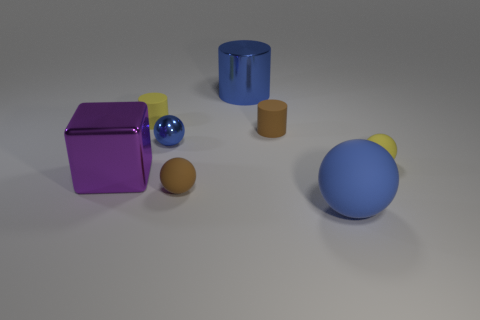Is the color of the large shiny cylinder the same as the large thing in front of the big purple metallic object?
Offer a terse response. Yes. What shape is the big blue metallic object?
Your answer should be compact. Cylinder. What number of big blocks have the same color as the tiny metal object?
Your response must be concise. 0. The big rubber thing that is the same shape as the small blue object is what color?
Provide a succinct answer. Blue. How many brown things are in front of the tiny rubber ball that is left of the large blue matte object?
Your answer should be very brief. 0. How many spheres are small blue objects or large rubber objects?
Ensure brevity in your answer.  2. Are any small cyan shiny things visible?
Ensure brevity in your answer.  No. What is the size of the other brown thing that is the same shape as the big matte object?
Provide a succinct answer. Small. The yellow thing behind the cylinder in front of the yellow rubber cylinder is what shape?
Offer a very short reply. Cylinder. How many purple objects are either metallic things or small shiny objects?
Offer a very short reply. 1. 